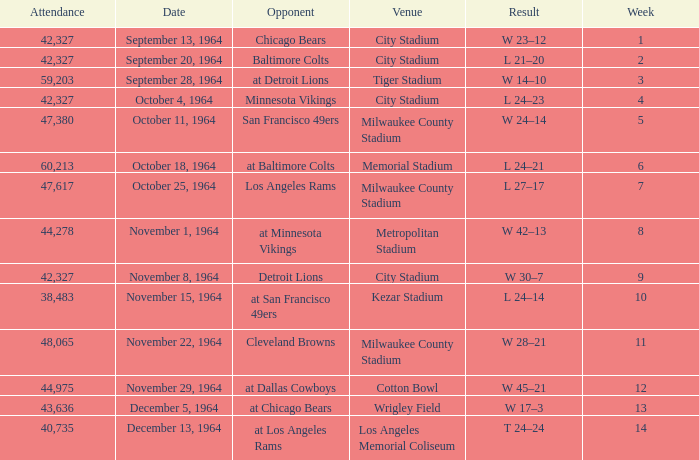What venue held that game with a result of l 24–14? Kezar Stadium. 